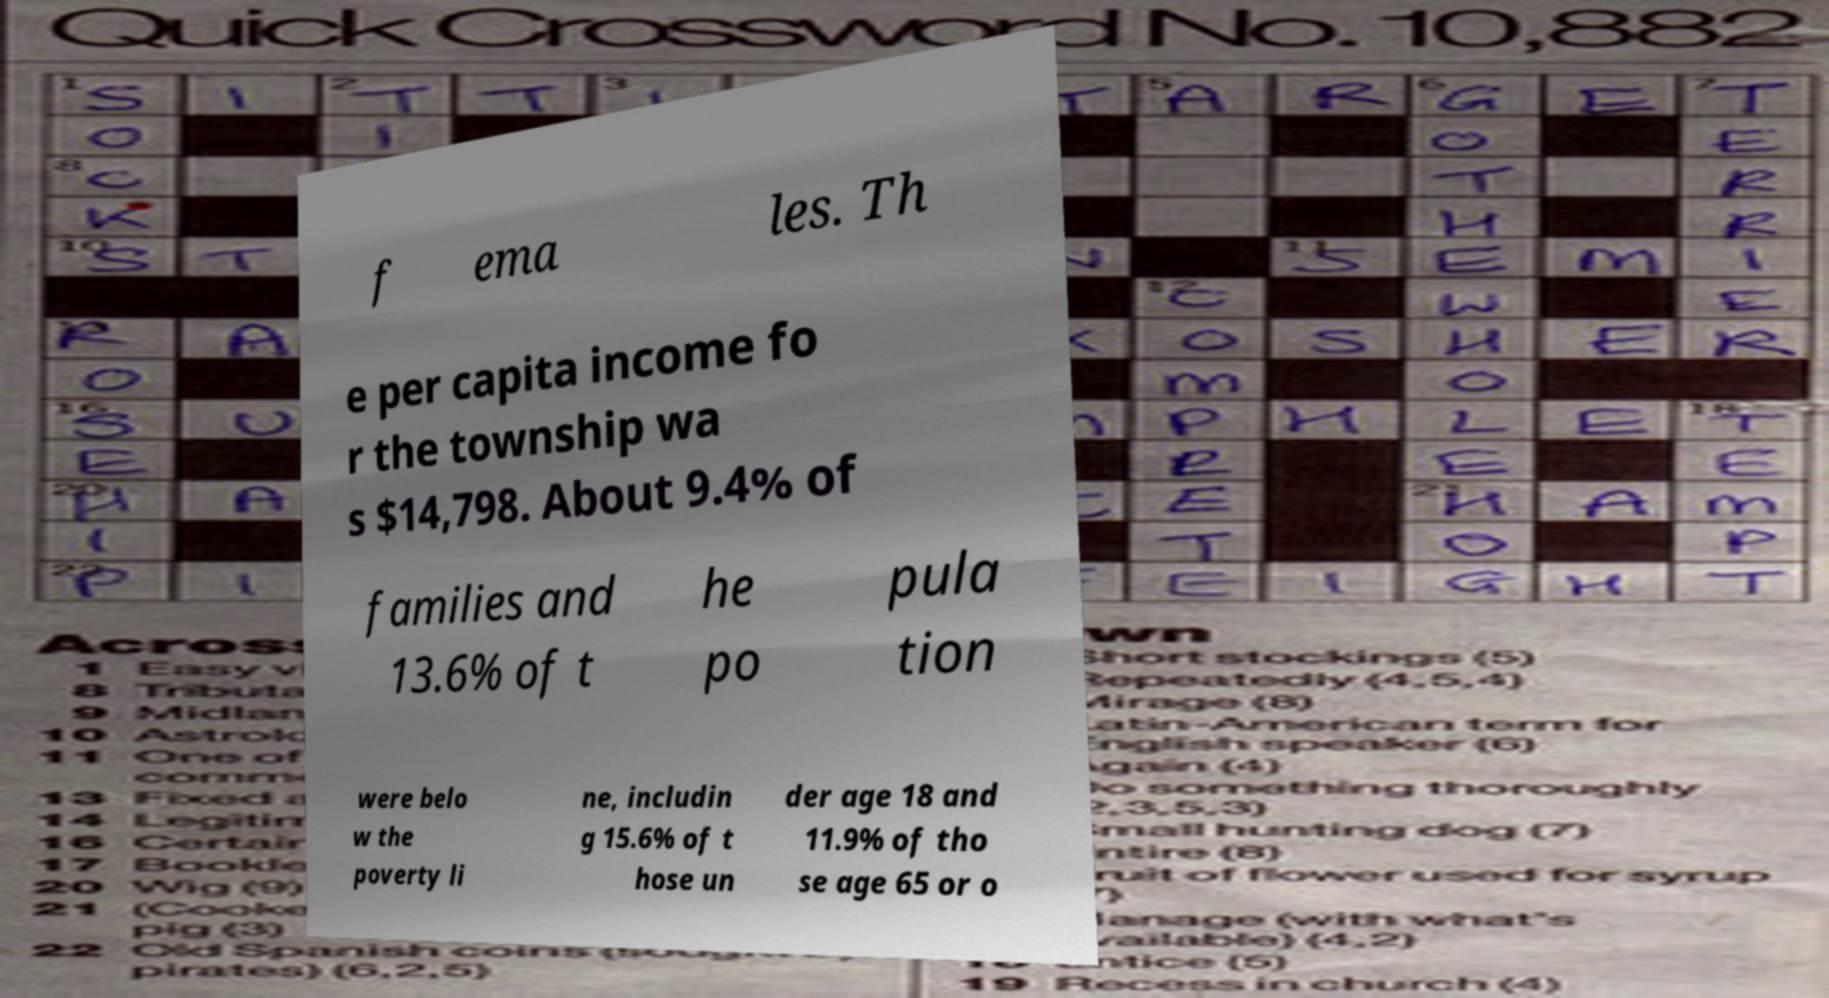Can you accurately transcribe the text from the provided image for me? f ema les. Th e per capita income fo r the township wa s $14,798. About 9.4% of families and 13.6% of t he po pula tion were belo w the poverty li ne, includin g 15.6% of t hose un der age 18 and 11.9% of tho se age 65 or o 